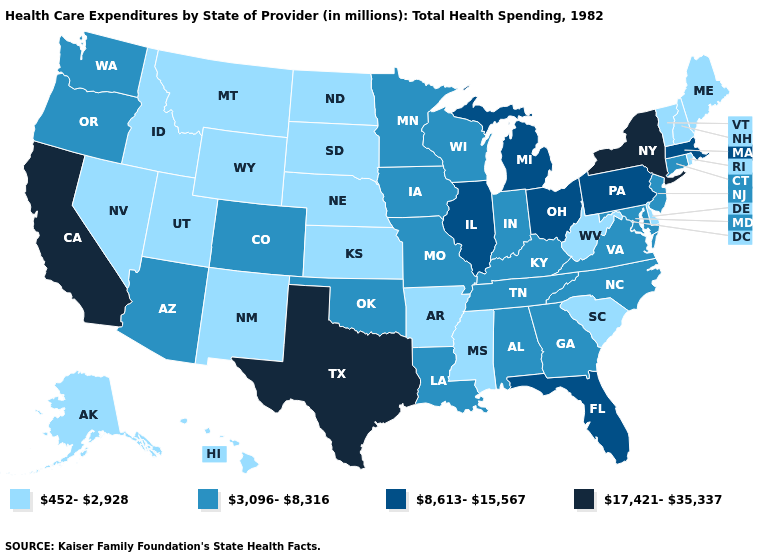Among the states that border Georgia , does South Carolina have the lowest value?
Keep it brief. Yes. What is the value of Wyoming?
Give a very brief answer. 452-2,928. What is the value of Delaware?
Quick response, please. 452-2,928. Among the states that border Oregon , does Nevada have the highest value?
Answer briefly. No. What is the highest value in states that border Michigan?
Concise answer only. 8,613-15,567. Among the states that border Alabama , does Florida have the highest value?
Keep it brief. Yes. What is the value of Vermont?
Be succinct. 452-2,928. What is the value of North Dakota?
Give a very brief answer. 452-2,928. Name the states that have a value in the range 3,096-8,316?
Short answer required. Alabama, Arizona, Colorado, Connecticut, Georgia, Indiana, Iowa, Kentucky, Louisiana, Maryland, Minnesota, Missouri, New Jersey, North Carolina, Oklahoma, Oregon, Tennessee, Virginia, Washington, Wisconsin. Name the states that have a value in the range 8,613-15,567?
Quick response, please. Florida, Illinois, Massachusetts, Michigan, Ohio, Pennsylvania. Among the states that border Tennessee , which have the lowest value?
Short answer required. Arkansas, Mississippi. Does the map have missing data?
Answer briefly. No. How many symbols are there in the legend?
Write a very short answer. 4. What is the lowest value in the USA?
Be succinct. 452-2,928. How many symbols are there in the legend?
Concise answer only. 4. 